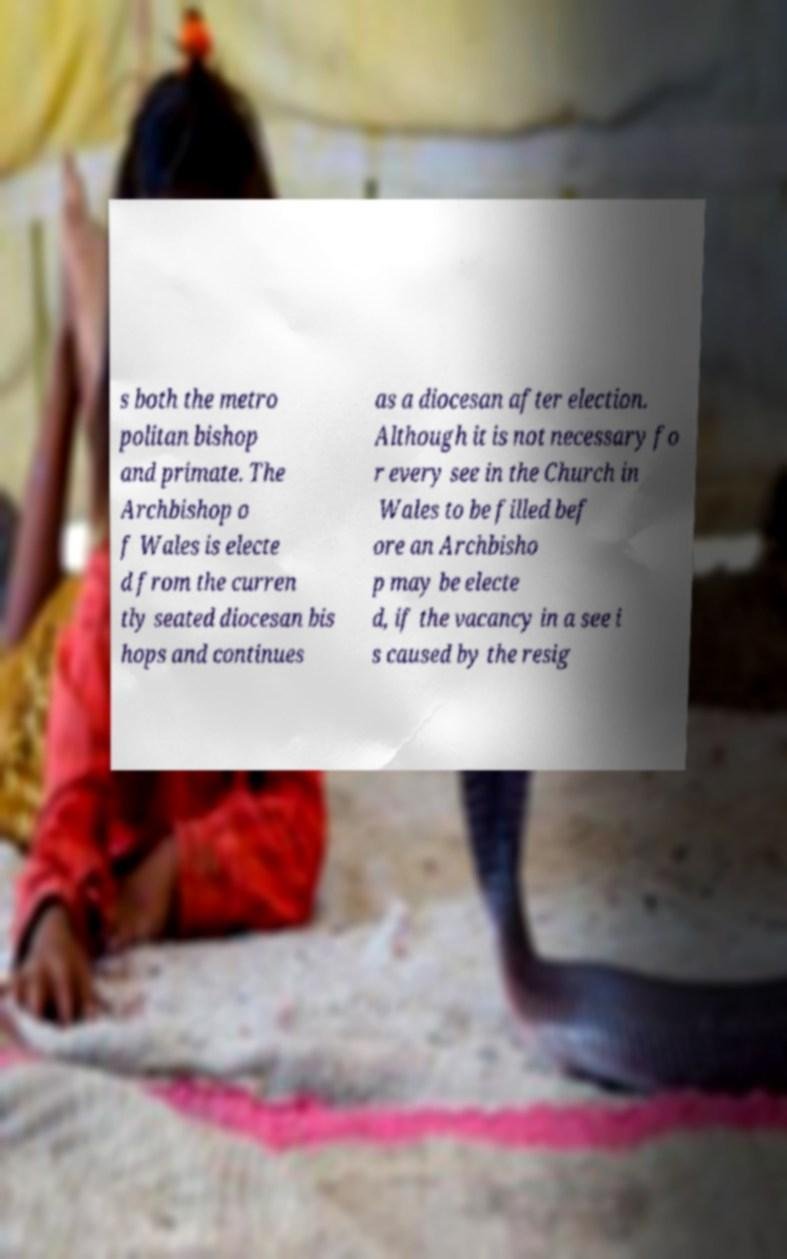There's text embedded in this image that I need extracted. Can you transcribe it verbatim? s both the metro politan bishop and primate. The Archbishop o f Wales is electe d from the curren tly seated diocesan bis hops and continues as a diocesan after election. Although it is not necessary fo r every see in the Church in Wales to be filled bef ore an Archbisho p may be electe d, if the vacancy in a see i s caused by the resig 